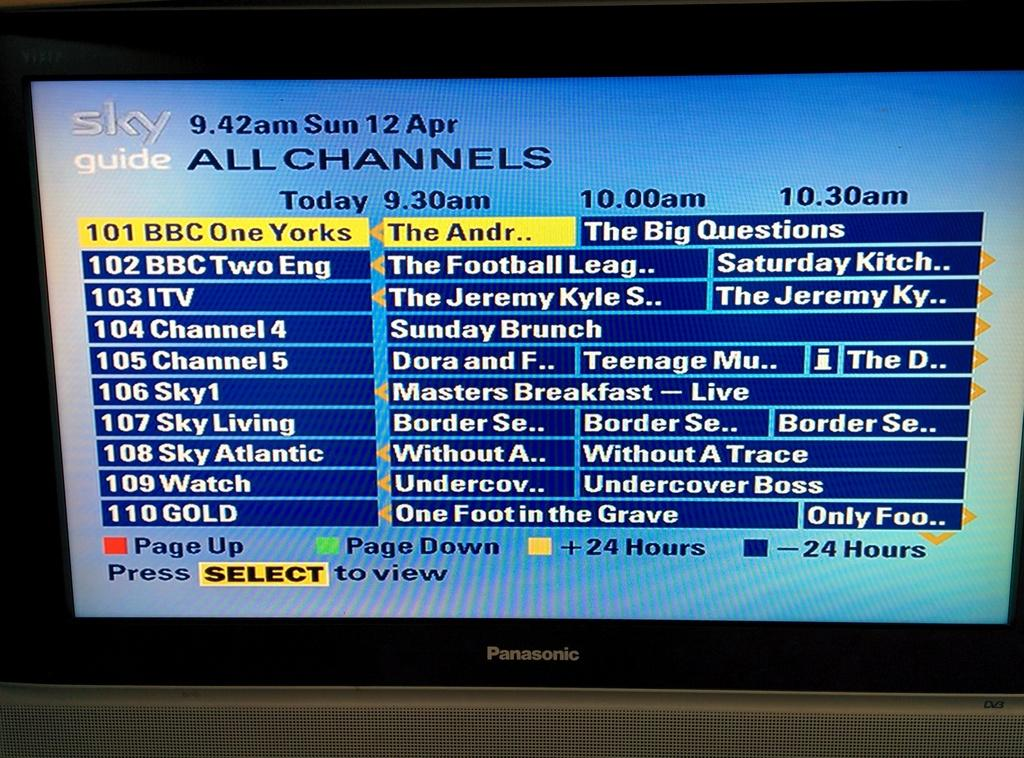<image>
Offer a succinct explanation of the picture presented. a television is open to the sky guide all channels screen 